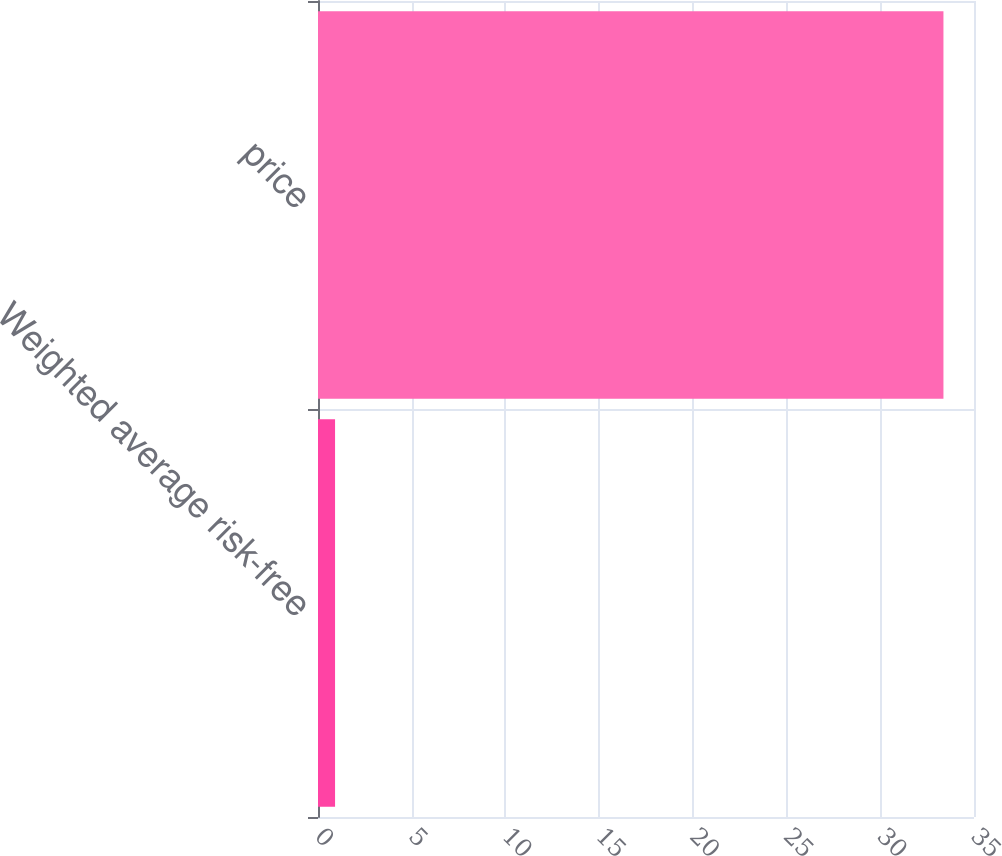Convert chart to OTSL. <chart><loc_0><loc_0><loc_500><loc_500><bar_chart><fcel>Weighted average risk-free<fcel>price<nl><fcel>0.91<fcel>33.37<nl></chart> 